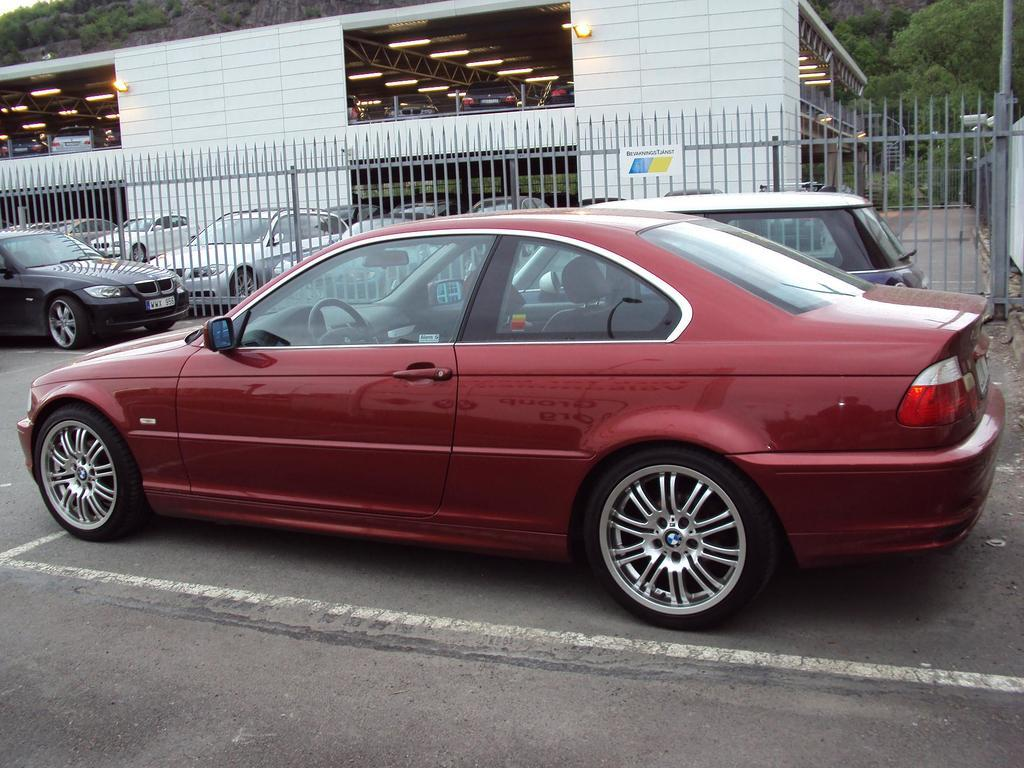What is the main subject of the image? There is a car on a road in the image. What can be seen behind the car? There is a fencing behind the car. What else is visible in the background of the image? There are cars and a shed visible in the background of the image. What natural feature can be seen in the background of the image? There is a mountain in the background of the image. What type of advertisement can be seen on the side of the car? There is no advertisement visible on the side of the car in the image. What type of carriage is being pulled by the horses in the image? There are no horses or carriages present in the image. 